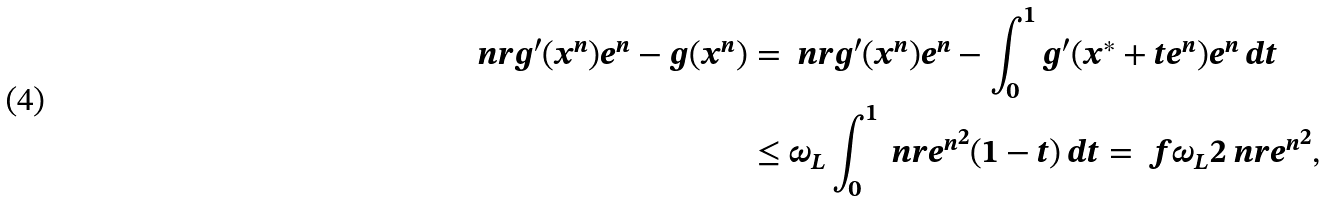Convert formula to latex. <formula><loc_0><loc_0><loc_500><loc_500>\ n r { g ^ { \prime } ( x ^ { n } ) e ^ { n } - g ( x ^ { n } ) } & = \ n r { g ^ { \prime } ( x ^ { n } ) e ^ { n } - \int _ { 0 } ^ { 1 } g ^ { \prime } ( x ^ { \ast } + t e ^ { n } ) e ^ { n } \, d t } \\ & \leq \omega _ { L } \int _ { 0 } ^ { 1 } \ n r { e ^ { n } } ^ { 2 } ( 1 - t ) \, d t = \ f { \omega _ { L } } 2 \ n r { e ^ { n } } ^ { 2 } ,</formula> 